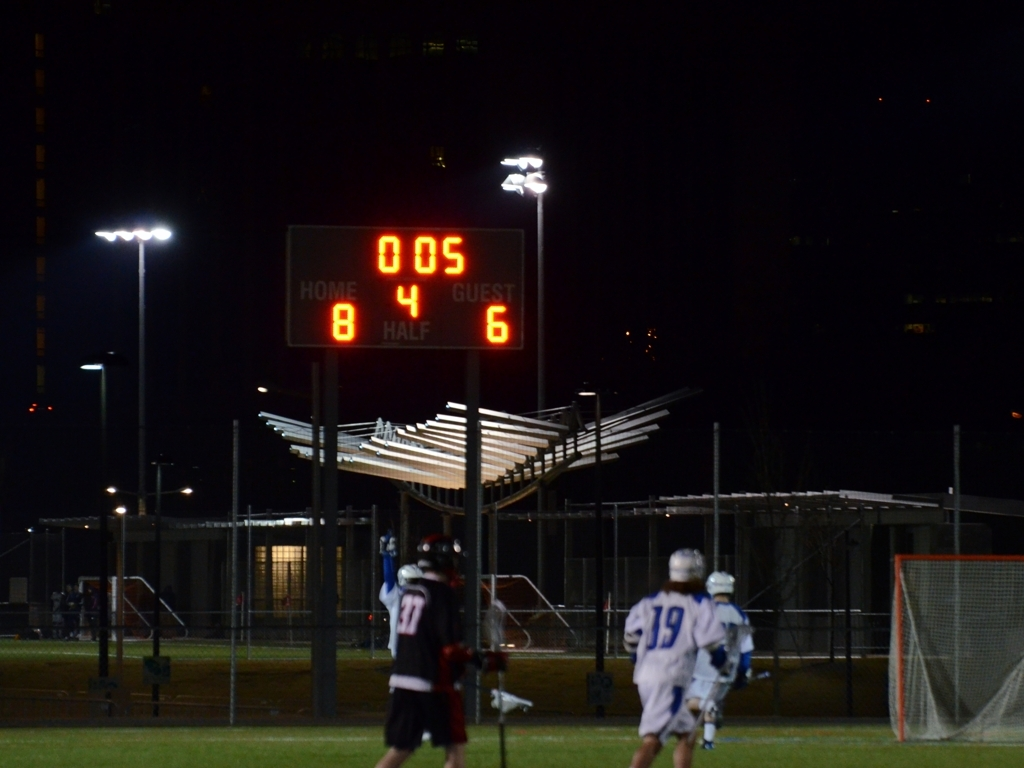What can you tell me about this sport? Based on the attire and equipment visible, it seems to be a lacrosse match taking place during nighttime under artificial lighting. Lacrosse is a team sport where players use a stick with a net to carry, pass, and shoot the ball into the opposing team's goal. 